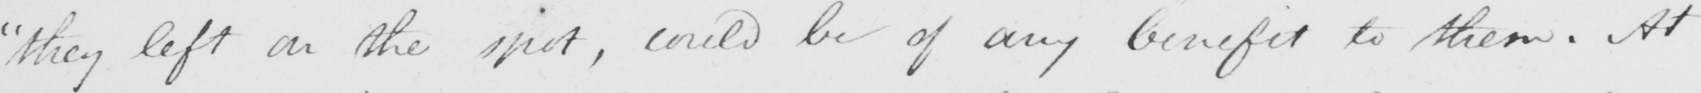What text is written in this handwritten line? " they left on the spot , could be of any benefit to them . At 